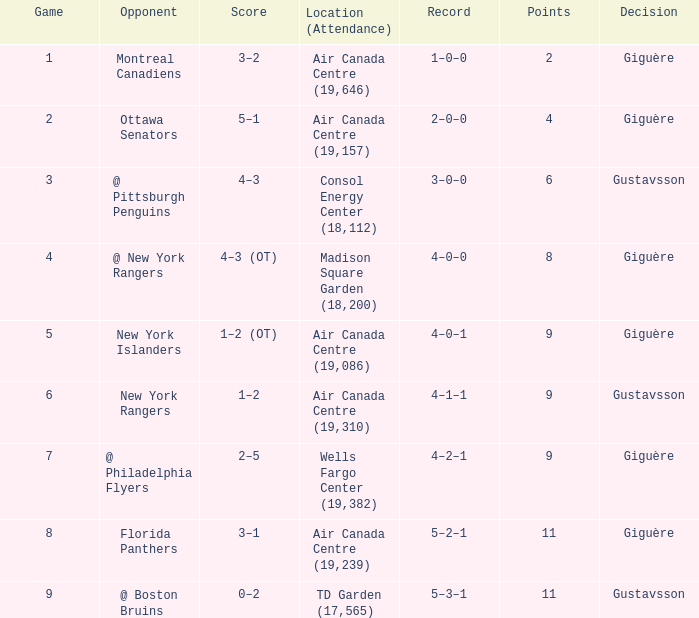What was the score for the opponent florida panthers? 1.0. Give me the full table as a dictionary. {'header': ['Game', 'Opponent', 'Score', 'Location (Attendance)', 'Record', 'Points', 'Decision'], 'rows': [['1', 'Montreal Canadiens', '3–2', 'Air Canada Centre (19,646)', '1–0–0', '2', 'Giguère'], ['2', 'Ottawa Senators', '5–1', 'Air Canada Centre (19,157)', '2–0–0', '4', 'Giguère'], ['3', '@ Pittsburgh Penguins', '4–3', 'Consol Energy Center (18,112)', '3–0–0', '6', 'Gustavsson'], ['4', '@ New York Rangers', '4–3 (OT)', 'Madison Square Garden (18,200)', '4–0–0', '8', 'Giguère'], ['5', 'New York Islanders', '1–2 (OT)', 'Air Canada Centre (19,086)', '4–0–1', '9', 'Giguère'], ['6', 'New York Rangers', '1–2', 'Air Canada Centre (19,310)', '4–1–1', '9', 'Gustavsson'], ['7', '@ Philadelphia Flyers', '2–5', 'Wells Fargo Center (19,382)', '4–2–1', '9', 'Giguère'], ['8', 'Florida Panthers', '3–1', 'Air Canada Centre (19,239)', '5–2–1', '11', 'Giguère'], ['9', '@ Boston Bruins', '0–2', 'TD Garden (17,565)', '5–3–1', '11', 'Gustavsson']]} 